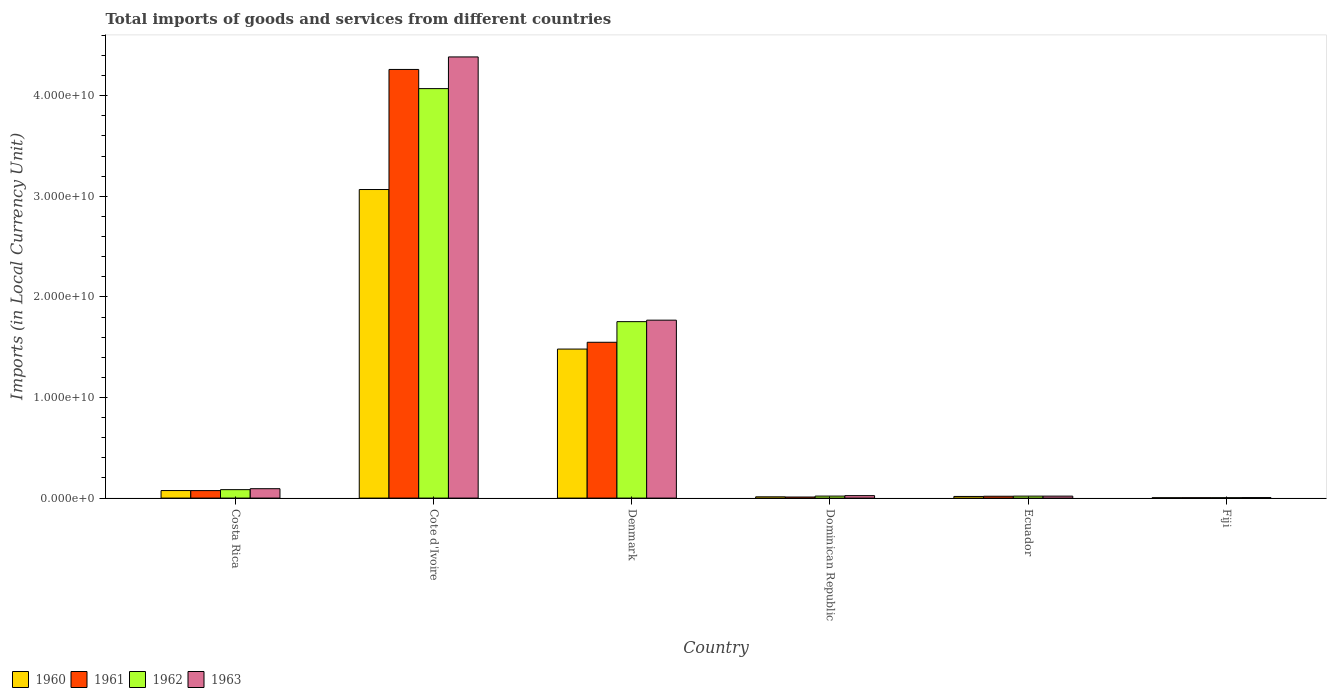How many different coloured bars are there?
Provide a short and direct response. 4. How many groups of bars are there?
Offer a very short reply. 6. Are the number of bars on each tick of the X-axis equal?
Give a very brief answer. Yes. How many bars are there on the 2nd tick from the right?
Give a very brief answer. 4. Across all countries, what is the maximum Amount of goods and services imports in 1962?
Offer a terse response. 4.07e+1. Across all countries, what is the minimum Amount of goods and services imports in 1960?
Your answer should be very brief. 3.56e+07. In which country was the Amount of goods and services imports in 1962 maximum?
Your answer should be very brief. Cote d'Ivoire. In which country was the Amount of goods and services imports in 1960 minimum?
Ensure brevity in your answer.  Fiji. What is the total Amount of goods and services imports in 1963 in the graph?
Ensure brevity in your answer.  6.30e+1. What is the difference between the Amount of goods and services imports in 1963 in Costa Rica and that in Denmark?
Provide a succinct answer. -1.68e+1. What is the difference between the Amount of goods and services imports in 1962 in Dominican Republic and the Amount of goods and services imports in 1961 in Cote d'Ivoire?
Your answer should be compact. -4.24e+1. What is the average Amount of goods and services imports in 1960 per country?
Your answer should be very brief. 7.76e+09. What is the difference between the Amount of goods and services imports of/in 1960 and Amount of goods and services imports of/in 1963 in Dominican Republic?
Give a very brief answer. -1.18e+08. In how many countries, is the Amount of goods and services imports in 1960 greater than 18000000000 LCU?
Ensure brevity in your answer.  1. What is the ratio of the Amount of goods and services imports in 1960 in Cote d'Ivoire to that in Fiji?
Make the answer very short. 861.66. Is the Amount of goods and services imports in 1960 in Dominican Republic less than that in Ecuador?
Provide a succinct answer. Yes. Is the difference between the Amount of goods and services imports in 1960 in Cote d'Ivoire and Denmark greater than the difference between the Amount of goods and services imports in 1963 in Cote d'Ivoire and Denmark?
Keep it short and to the point. No. What is the difference between the highest and the second highest Amount of goods and services imports in 1963?
Offer a terse response. 1.68e+1. What is the difference between the highest and the lowest Amount of goods and services imports in 1963?
Provide a short and direct response. 4.38e+1. In how many countries, is the Amount of goods and services imports in 1960 greater than the average Amount of goods and services imports in 1960 taken over all countries?
Your answer should be compact. 2. Is the sum of the Amount of goods and services imports in 1963 in Costa Rica and Denmark greater than the maximum Amount of goods and services imports in 1960 across all countries?
Ensure brevity in your answer.  No. What does the 3rd bar from the left in Denmark represents?
Your answer should be very brief. 1962. What does the 1st bar from the right in Cote d'Ivoire represents?
Provide a succinct answer. 1963. How many bars are there?
Give a very brief answer. 24. Does the graph contain any zero values?
Provide a succinct answer. No. Does the graph contain grids?
Your answer should be very brief. No. How many legend labels are there?
Offer a terse response. 4. What is the title of the graph?
Keep it short and to the point. Total imports of goods and services from different countries. Does "2005" appear as one of the legend labels in the graph?
Your answer should be compact. No. What is the label or title of the X-axis?
Make the answer very short. Country. What is the label or title of the Y-axis?
Offer a very short reply. Imports (in Local Currency Unit). What is the Imports (in Local Currency Unit) in 1960 in Costa Rica?
Your response must be concise. 7.49e+08. What is the Imports (in Local Currency Unit) in 1961 in Costa Rica?
Make the answer very short. 7.44e+08. What is the Imports (in Local Currency Unit) in 1962 in Costa Rica?
Keep it short and to the point. 8.40e+08. What is the Imports (in Local Currency Unit) of 1963 in Costa Rica?
Ensure brevity in your answer.  9.34e+08. What is the Imports (in Local Currency Unit) in 1960 in Cote d'Ivoire?
Your answer should be very brief. 3.07e+1. What is the Imports (in Local Currency Unit) of 1961 in Cote d'Ivoire?
Give a very brief answer. 4.26e+1. What is the Imports (in Local Currency Unit) in 1962 in Cote d'Ivoire?
Your answer should be compact. 4.07e+1. What is the Imports (in Local Currency Unit) of 1963 in Cote d'Ivoire?
Offer a very short reply. 4.39e+1. What is the Imports (in Local Currency Unit) in 1960 in Denmark?
Your answer should be very brief. 1.48e+1. What is the Imports (in Local Currency Unit) in 1961 in Denmark?
Give a very brief answer. 1.55e+1. What is the Imports (in Local Currency Unit) in 1962 in Denmark?
Give a very brief answer. 1.75e+1. What is the Imports (in Local Currency Unit) of 1963 in Denmark?
Make the answer very short. 1.77e+1. What is the Imports (in Local Currency Unit) of 1960 in Dominican Republic?
Offer a very short reply. 1.26e+08. What is the Imports (in Local Currency Unit) in 1961 in Dominican Republic?
Provide a short and direct response. 1.07e+08. What is the Imports (in Local Currency Unit) of 1962 in Dominican Republic?
Ensure brevity in your answer.  1.99e+08. What is the Imports (in Local Currency Unit) of 1963 in Dominican Republic?
Your answer should be very brief. 2.44e+08. What is the Imports (in Local Currency Unit) in 1960 in Ecuador?
Your answer should be compact. 1.64e+08. What is the Imports (in Local Currency Unit) in 1961 in Ecuador?
Offer a terse response. 1.83e+08. What is the Imports (in Local Currency Unit) of 1962 in Ecuador?
Provide a succinct answer. 1.97e+08. What is the Imports (in Local Currency Unit) of 1963 in Ecuador?
Provide a succinct answer. 1.96e+08. What is the Imports (in Local Currency Unit) in 1960 in Fiji?
Make the answer very short. 3.56e+07. What is the Imports (in Local Currency Unit) of 1961 in Fiji?
Offer a terse response. 3.79e+07. What is the Imports (in Local Currency Unit) in 1962 in Fiji?
Make the answer very short. 3.79e+07. What is the Imports (in Local Currency Unit) of 1963 in Fiji?
Offer a very short reply. 5.00e+07. Across all countries, what is the maximum Imports (in Local Currency Unit) in 1960?
Keep it short and to the point. 3.07e+1. Across all countries, what is the maximum Imports (in Local Currency Unit) of 1961?
Your response must be concise. 4.26e+1. Across all countries, what is the maximum Imports (in Local Currency Unit) of 1962?
Offer a terse response. 4.07e+1. Across all countries, what is the maximum Imports (in Local Currency Unit) of 1963?
Provide a succinct answer. 4.39e+1. Across all countries, what is the minimum Imports (in Local Currency Unit) in 1960?
Ensure brevity in your answer.  3.56e+07. Across all countries, what is the minimum Imports (in Local Currency Unit) in 1961?
Make the answer very short. 3.79e+07. Across all countries, what is the minimum Imports (in Local Currency Unit) of 1962?
Your answer should be very brief. 3.79e+07. What is the total Imports (in Local Currency Unit) in 1960 in the graph?
Offer a terse response. 4.66e+1. What is the total Imports (in Local Currency Unit) in 1961 in the graph?
Make the answer very short. 5.92e+1. What is the total Imports (in Local Currency Unit) of 1962 in the graph?
Provide a succinct answer. 5.95e+1. What is the total Imports (in Local Currency Unit) of 1963 in the graph?
Your answer should be compact. 6.30e+1. What is the difference between the Imports (in Local Currency Unit) of 1960 in Costa Rica and that in Cote d'Ivoire?
Make the answer very short. -2.99e+1. What is the difference between the Imports (in Local Currency Unit) in 1961 in Costa Rica and that in Cote d'Ivoire?
Ensure brevity in your answer.  -4.19e+1. What is the difference between the Imports (in Local Currency Unit) of 1962 in Costa Rica and that in Cote d'Ivoire?
Provide a short and direct response. -3.99e+1. What is the difference between the Imports (in Local Currency Unit) of 1963 in Costa Rica and that in Cote d'Ivoire?
Ensure brevity in your answer.  -4.29e+1. What is the difference between the Imports (in Local Currency Unit) of 1960 in Costa Rica and that in Denmark?
Provide a short and direct response. -1.41e+1. What is the difference between the Imports (in Local Currency Unit) of 1961 in Costa Rica and that in Denmark?
Your answer should be compact. -1.47e+1. What is the difference between the Imports (in Local Currency Unit) in 1962 in Costa Rica and that in Denmark?
Offer a terse response. -1.67e+1. What is the difference between the Imports (in Local Currency Unit) in 1963 in Costa Rica and that in Denmark?
Give a very brief answer. -1.68e+1. What is the difference between the Imports (in Local Currency Unit) of 1960 in Costa Rica and that in Dominican Republic?
Keep it short and to the point. 6.22e+08. What is the difference between the Imports (in Local Currency Unit) in 1961 in Costa Rica and that in Dominican Republic?
Your answer should be very brief. 6.37e+08. What is the difference between the Imports (in Local Currency Unit) of 1962 in Costa Rica and that in Dominican Republic?
Make the answer very short. 6.40e+08. What is the difference between the Imports (in Local Currency Unit) of 1963 in Costa Rica and that in Dominican Republic?
Your response must be concise. 6.90e+08. What is the difference between the Imports (in Local Currency Unit) of 1960 in Costa Rica and that in Ecuador?
Your response must be concise. 5.85e+08. What is the difference between the Imports (in Local Currency Unit) in 1961 in Costa Rica and that in Ecuador?
Offer a very short reply. 5.61e+08. What is the difference between the Imports (in Local Currency Unit) of 1962 in Costa Rica and that in Ecuador?
Provide a short and direct response. 6.43e+08. What is the difference between the Imports (in Local Currency Unit) in 1963 in Costa Rica and that in Ecuador?
Give a very brief answer. 7.38e+08. What is the difference between the Imports (in Local Currency Unit) of 1960 in Costa Rica and that in Fiji?
Your answer should be very brief. 7.13e+08. What is the difference between the Imports (in Local Currency Unit) of 1961 in Costa Rica and that in Fiji?
Your answer should be compact. 7.06e+08. What is the difference between the Imports (in Local Currency Unit) in 1962 in Costa Rica and that in Fiji?
Ensure brevity in your answer.  8.02e+08. What is the difference between the Imports (in Local Currency Unit) of 1963 in Costa Rica and that in Fiji?
Offer a very short reply. 8.84e+08. What is the difference between the Imports (in Local Currency Unit) in 1960 in Cote d'Ivoire and that in Denmark?
Keep it short and to the point. 1.59e+1. What is the difference between the Imports (in Local Currency Unit) in 1961 in Cote d'Ivoire and that in Denmark?
Provide a succinct answer. 2.71e+1. What is the difference between the Imports (in Local Currency Unit) in 1962 in Cote d'Ivoire and that in Denmark?
Provide a succinct answer. 2.32e+1. What is the difference between the Imports (in Local Currency Unit) of 1963 in Cote d'Ivoire and that in Denmark?
Your response must be concise. 2.62e+1. What is the difference between the Imports (in Local Currency Unit) of 1960 in Cote d'Ivoire and that in Dominican Republic?
Offer a terse response. 3.05e+1. What is the difference between the Imports (in Local Currency Unit) of 1961 in Cote d'Ivoire and that in Dominican Republic?
Provide a succinct answer. 4.25e+1. What is the difference between the Imports (in Local Currency Unit) of 1962 in Cote d'Ivoire and that in Dominican Republic?
Your answer should be compact. 4.05e+1. What is the difference between the Imports (in Local Currency Unit) in 1963 in Cote d'Ivoire and that in Dominican Republic?
Ensure brevity in your answer.  4.36e+1. What is the difference between the Imports (in Local Currency Unit) in 1960 in Cote d'Ivoire and that in Ecuador?
Ensure brevity in your answer.  3.05e+1. What is the difference between the Imports (in Local Currency Unit) in 1961 in Cote d'Ivoire and that in Ecuador?
Your answer should be compact. 4.24e+1. What is the difference between the Imports (in Local Currency Unit) of 1962 in Cote d'Ivoire and that in Ecuador?
Give a very brief answer. 4.05e+1. What is the difference between the Imports (in Local Currency Unit) in 1963 in Cote d'Ivoire and that in Ecuador?
Offer a terse response. 4.37e+1. What is the difference between the Imports (in Local Currency Unit) in 1960 in Cote d'Ivoire and that in Fiji?
Make the answer very short. 3.06e+1. What is the difference between the Imports (in Local Currency Unit) of 1961 in Cote d'Ivoire and that in Fiji?
Keep it short and to the point. 4.26e+1. What is the difference between the Imports (in Local Currency Unit) in 1962 in Cote d'Ivoire and that in Fiji?
Offer a very short reply. 4.07e+1. What is the difference between the Imports (in Local Currency Unit) in 1963 in Cote d'Ivoire and that in Fiji?
Your response must be concise. 4.38e+1. What is the difference between the Imports (in Local Currency Unit) in 1960 in Denmark and that in Dominican Republic?
Ensure brevity in your answer.  1.47e+1. What is the difference between the Imports (in Local Currency Unit) of 1961 in Denmark and that in Dominican Republic?
Your answer should be compact. 1.54e+1. What is the difference between the Imports (in Local Currency Unit) in 1962 in Denmark and that in Dominican Republic?
Keep it short and to the point. 1.73e+1. What is the difference between the Imports (in Local Currency Unit) of 1963 in Denmark and that in Dominican Republic?
Offer a terse response. 1.74e+1. What is the difference between the Imports (in Local Currency Unit) in 1960 in Denmark and that in Ecuador?
Offer a very short reply. 1.47e+1. What is the difference between the Imports (in Local Currency Unit) in 1961 in Denmark and that in Ecuador?
Give a very brief answer. 1.53e+1. What is the difference between the Imports (in Local Currency Unit) in 1962 in Denmark and that in Ecuador?
Ensure brevity in your answer.  1.73e+1. What is the difference between the Imports (in Local Currency Unit) of 1963 in Denmark and that in Ecuador?
Your answer should be very brief. 1.75e+1. What is the difference between the Imports (in Local Currency Unit) of 1960 in Denmark and that in Fiji?
Your answer should be compact. 1.48e+1. What is the difference between the Imports (in Local Currency Unit) of 1961 in Denmark and that in Fiji?
Ensure brevity in your answer.  1.55e+1. What is the difference between the Imports (in Local Currency Unit) of 1962 in Denmark and that in Fiji?
Your answer should be compact. 1.75e+1. What is the difference between the Imports (in Local Currency Unit) of 1963 in Denmark and that in Fiji?
Keep it short and to the point. 1.76e+1. What is the difference between the Imports (in Local Currency Unit) of 1960 in Dominican Republic and that in Ecuador?
Offer a very short reply. -3.75e+07. What is the difference between the Imports (in Local Currency Unit) in 1961 in Dominican Republic and that in Ecuador?
Offer a terse response. -7.66e+07. What is the difference between the Imports (in Local Currency Unit) of 1962 in Dominican Republic and that in Ecuador?
Give a very brief answer. 2.37e+06. What is the difference between the Imports (in Local Currency Unit) in 1963 in Dominican Republic and that in Ecuador?
Keep it short and to the point. 4.81e+07. What is the difference between the Imports (in Local Currency Unit) of 1960 in Dominican Republic and that in Fiji?
Your response must be concise. 9.09e+07. What is the difference between the Imports (in Local Currency Unit) of 1961 in Dominican Republic and that in Fiji?
Provide a succinct answer. 6.90e+07. What is the difference between the Imports (in Local Currency Unit) in 1962 in Dominican Republic and that in Fiji?
Give a very brief answer. 1.61e+08. What is the difference between the Imports (in Local Currency Unit) in 1963 in Dominican Republic and that in Fiji?
Ensure brevity in your answer.  1.94e+08. What is the difference between the Imports (in Local Currency Unit) in 1960 in Ecuador and that in Fiji?
Offer a terse response. 1.28e+08. What is the difference between the Imports (in Local Currency Unit) of 1961 in Ecuador and that in Fiji?
Keep it short and to the point. 1.46e+08. What is the difference between the Imports (in Local Currency Unit) of 1962 in Ecuador and that in Fiji?
Make the answer very short. 1.59e+08. What is the difference between the Imports (in Local Currency Unit) in 1963 in Ecuador and that in Fiji?
Provide a short and direct response. 1.46e+08. What is the difference between the Imports (in Local Currency Unit) of 1960 in Costa Rica and the Imports (in Local Currency Unit) of 1961 in Cote d'Ivoire?
Make the answer very short. -4.19e+1. What is the difference between the Imports (in Local Currency Unit) in 1960 in Costa Rica and the Imports (in Local Currency Unit) in 1962 in Cote d'Ivoire?
Your response must be concise. -4.00e+1. What is the difference between the Imports (in Local Currency Unit) of 1960 in Costa Rica and the Imports (in Local Currency Unit) of 1963 in Cote d'Ivoire?
Give a very brief answer. -4.31e+1. What is the difference between the Imports (in Local Currency Unit) of 1961 in Costa Rica and the Imports (in Local Currency Unit) of 1962 in Cote d'Ivoire?
Your answer should be very brief. -4.00e+1. What is the difference between the Imports (in Local Currency Unit) of 1961 in Costa Rica and the Imports (in Local Currency Unit) of 1963 in Cote d'Ivoire?
Keep it short and to the point. -4.31e+1. What is the difference between the Imports (in Local Currency Unit) in 1962 in Costa Rica and the Imports (in Local Currency Unit) in 1963 in Cote d'Ivoire?
Your answer should be compact. -4.30e+1. What is the difference between the Imports (in Local Currency Unit) in 1960 in Costa Rica and the Imports (in Local Currency Unit) in 1961 in Denmark?
Give a very brief answer. -1.47e+1. What is the difference between the Imports (in Local Currency Unit) of 1960 in Costa Rica and the Imports (in Local Currency Unit) of 1962 in Denmark?
Give a very brief answer. -1.68e+1. What is the difference between the Imports (in Local Currency Unit) in 1960 in Costa Rica and the Imports (in Local Currency Unit) in 1963 in Denmark?
Offer a very short reply. -1.69e+1. What is the difference between the Imports (in Local Currency Unit) of 1961 in Costa Rica and the Imports (in Local Currency Unit) of 1962 in Denmark?
Your answer should be very brief. -1.68e+1. What is the difference between the Imports (in Local Currency Unit) of 1961 in Costa Rica and the Imports (in Local Currency Unit) of 1963 in Denmark?
Your answer should be compact. -1.69e+1. What is the difference between the Imports (in Local Currency Unit) of 1962 in Costa Rica and the Imports (in Local Currency Unit) of 1963 in Denmark?
Make the answer very short. -1.68e+1. What is the difference between the Imports (in Local Currency Unit) in 1960 in Costa Rica and the Imports (in Local Currency Unit) in 1961 in Dominican Republic?
Provide a succinct answer. 6.42e+08. What is the difference between the Imports (in Local Currency Unit) of 1960 in Costa Rica and the Imports (in Local Currency Unit) of 1962 in Dominican Republic?
Ensure brevity in your answer.  5.50e+08. What is the difference between the Imports (in Local Currency Unit) of 1960 in Costa Rica and the Imports (in Local Currency Unit) of 1963 in Dominican Republic?
Your answer should be compact. 5.04e+08. What is the difference between the Imports (in Local Currency Unit) in 1961 in Costa Rica and the Imports (in Local Currency Unit) in 1962 in Dominican Republic?
Your answer should be very brief. 5.45e+08. What is the difference between the Imports (in Local Currency Unit) of 1961 in Costa Rica and the Imports (in Local Currency Unit) of 1963 in Dominican Republic?
Your answer should be very brief. 5.00e+08. What is the difference between the Imports (in Local Currency Unit) of 1962 in Costa Rica and the Imports (in Local Currency Unit) of 1963 in Dominican Republic?
Keep it short and to the point. 5.95e+08. What is the difference between the Imports (in Local Currency Unit) of 1960 in Costa Rica and the Imports (in Local Currency Unit) of 1961 in Ecuador?
Offer a terse response. 5.65e+08. What is the difference between the Imports (in Local Currency Unit) in 1960 in Costa Rica and the Imports (in Local Currency Unit) in 1962 in Ecuador?
Ensure brevity in your answer.  5.52e+08. What is the difference between the Imports (in Local Currency Unit) of 1960 in Costa Rica and the Imports (in Local Currency Unit) of 1963 in Ecuador?
Give a very brief answer. 5.53e+08. What is the difference between the Imports (in Local Currency Unit) of 1961 in Costa Rica and the Imports (in Local Currency Unit) of 1962 in Ecuador?
Provide a short and direct response. 5.47e+08. What is the difference between the Imports (in Local Currency Unit) of 1961 in Costa Rica and the Imports (in Local Currency Unit) of 1963 in Ecuador?
Give a very brief answer. 5.48e+08. What is the difference between the Imports (in Local Currency Unit) of 1962 in Costa Rica and the Imports (in Local Currency Unit) of 1963 in Ecuador?
Make the answer very short. 6.43e+08. What is the difference between the Imports (in Local Currency Unit) of 1960 in Costa Rica and the Imports (in Local Currency Unit) of 1961 in Fiji?
Provide a succinct answer. 7.11e+08. What is the difference between the Imports (in Local Currency Unit) in 1960 in Costa Rica and the Imports (in Local Currency Unit) in 1962 in Fiji?
Offer a very short reply. 7.11e+08. What is the difference between the Imports (in Local Currency Unit) in 1960 in Costa Rica and the Imports (in Local Currency Unit) in 1963 in Fiji?
Offer a terse response. 6.99e+08. What is the difference between the Imports (in Local Currency Unit) in 1961 in Costa Rica and the Imports (in Local Currency Unit) in 1962 in Fiji?
Provide a short and direct response. 7.06e+08. What is the difference between the Imports (in Local Currency Unit) in 1961 in Costa Rica and the Imports (in Local Currency Unit) in 1963 in Fiji?
Give a very brief answer. 6.94e+08. What is the difference between the Imports (in Local Currency Unit) in 1962 in Costa Rica and the Imports (in Local Currency Unit) in 1963 in Fiji?
Your answer should be very brief. 7.90e+08. What is the difference between the Imports (in Local Currency Unit) of 1960 in Cote d'Ivoire and the Imports (in Local Currency Unit) of 1961 in Denmark?
Offer a very short reply. 1.52e+1. What is the difference between the Imports (in Local Currency Unit) of 1960 in Cote d'Ivoire and the Imports (in Local Currency Unit) of 1962 in Denmark?
Offer a very short reply. 1.31e+1. What is the difference between the Imports (in Local Currency Unit) of 1960 in Cote d'Ivoire and the Imports (in Local Currency Unit) of 1963 in Denmark?
Your answer should be very brief. 1.30e+1. What is the difference between the Imports (in Local Currency Unit) in 1961 in Cote d'Ivoire and the Imports (in Local Currency Unit) in 1962 in Denmark?
Offer a very short reply. 2.51e+1. What is the difference between the Imports (in Local Currency Unit) in 1961 in Cote d'Ivoire and the Imports (in Local Currency Unit) in 1963 in Denmark?
Make the answer very short. 2.49e+1. What is the difference between the Imports (in Local Currency Unit) in 1962 in Cote d'Ivoire and the Imports (in Local Currency Unit) in 1963 in Denmark?
Make the answer very short. 2.30e+1. What is the difference between the Imports (in Local Currency Unit) of 1960 in Cote d'Ivoire and the Imports (in Local Currency Unit) of 1961 in Dominican Republic?
Offer a terse response. 3.06e+1. What is the difference between the Imports (in Local Currency Unit) of 1960 in Cote d'Ivoire and the Imports (in Local Currency Unit) of 1962 in Dominican Republic?
Give a very brief answer. 3.05e+1. What is the difference between the Imports (in Local Currency Unit) of 1960 in Cote d'Ivoire and the Imports (in Local Currency Unit) of 1963 in Dominican Republic?
Give a very brief answer. 3.04e+1. What is the difference between the Imports (in Local Currency Unit) of 1961 in Cote d'Ivoire and the Imports (in Local Currency Unit) of 1962 in Dominican Republic?
Offer a very short reply. 4.24e+1. What is the difference between the Imports (in Local Currency Unit) of 1961 in Cote d'Ivoire and the Imports (in Local Currency Unit) of 1963 in Dominican Republic?
Offer a very short reply. 4.24e+1. What is the difference between the Imports (in Local Currency Unit) in 1962 in Cote d'Ivoire and the Imports (in Local Currency Unit) in 1963 in Dominican Republic?
Provide a succinct answer. 4.05e+1. What is the difference between the Imports (in Local Currency Unit) of 1960 in Cote d'Ivoire and the Imports (in Local Currency Unit) of 1961 in Ecuador?
Keep it short and to the point. 3.05e+1. What is the difference between the Imports (in Local Currency Unit) of 1960 in Cote d'Ivoire and the Imports (in Local Currency Unit) of 1962 in Ecuador?
Provide a succinct answer. 3.05e+1. What is the difference between the Imports (in Local Currency Unit) in 1960 in Cote d'Ivoire and the Imports (in Local Currency Unit) in 1963 in Ecuador?
Ensure brevity in your answer.  3.05e+1. What is the difference between the Imports (in Local Currency Unit) of 1961 in Cote d'Ivoire and the Imports (in Local Currency Unit) of 1962 in Ecuador?
Provide a short and direct response. 4.24e+1. What is the difference between the Imports (in Local Currency Unit) in 1961 in Cote d'Ivoire and the Imports (in Local Currency Unit) in 1963 in Ecuador?
Keep it short and to the point. 4.24e+1. What is the difference between the Imports (in Local Currency Unit) of 1962 in Cote d'Ivoire and the Imports (in Local Currency Unit) of 1963 in Ecuador?
Make the answer very short. 4.05e+1. What is the difference between the Imports (in Local Currency Unit) of 1960 in Cote d'Ivoire and the Imports (in Local Currency Unit) of 1961 in Fiji?
Provide a short and direct response. 3.06e+1. What is the difference between the Imports (in Local Currency Unit) in 1960 in Cote d'Ivoire and the Imports (in Local Currency Unit) in 1962 in Fiji?
Your response must be concise. 3.06e+1. What is the difference between the Imports (in Local Currency Unit) in 1960 in Cote d'Ivoire and the Imports (in Local Currency Unit) in 1963 in Fiji?
Keep it short and to the point. 3.06e+1. What is the difference between the Imports (in Local Currency Unit) in 1961 in Cote d'Ivoire and the Imports (in Local Currency Unit) in 1962 in Fiji?
Offer a terse response. 4.26e+1. What is the difference between the Imports (in Local Currency Unit) in 1961 in Cote d'Ivoire and the Imports (in Local Currency Unit) in 1963 in Fiji?
Make the answer very short. 4.26e+1. What is the difference between the Imports (in Local Currency Unit) in 1962 in Cote d'Ivoire and the Imports (in Local Currency Unit) in 1963 in Fiji?
Give a very brief answer. 4.07e+1. What is the difference between the Imports (in Local Currency Unit) in 1960 in Denmark and the Imports (in Local Currency Unit) in 1961 in Dominican Republic?
Your answer should be compact. 1.47e+1. What is the difference between the Imports (in Local Currency Unit) of 1960 in Denmark and the Imports (in Local Currency Unit) of 1962 in Dominican Republic?
Ensure brevity in your answer.  1.46e+1. What is the difference between the Imports (in Local Currency Unit) in 1960 in Denmark and the Imports (in Local Currency Unit) in 1963 in Dominican Republic?
Offer a very short reply. 1.46e+1. What is the difference between the Imports (in Local Currency Unit) of 1961 in Denmark and the Imports (in Local Currency Unit) of 1962 in Dominican Republic?
Your answer should be very brief. 1.53e+1. What is the difference between the Imports (in Local Currency Unit) in 1961 in Denmark and the Imports (in Local Currency Unit) in 1963 in Dominican Republic?
Ensure brevity in your answer.  1.52e+1. What is the difference between the Imports (in Local Currency Unit) of 1962 in Denmark and the Imports (in Local Currency Unit) of 1963 in Dominican Republic?
Your response must be concise. 1.73e+1. What is the difference between the Imports (in Local Currency Unit) in 1960 in Denmark and the Imports (in Local Currency Unit) in 1961 in Ecuador?
Offer a very short reply. 1.46e+1. What is the difference between the Imports (in Local Currency Unit) in 1960 in Denmark and the Imports (in Local Currency Unit) in 1962 in Ecuador?
Make the answer very short. 1.46e+1. What is the difference between the Imports (in Local Currency Unit) of 1960 in Denmark and the Imports (in Local Currency Unit) of 1963 in Ecuador?
Your answer should be very brief. 1.46e+1. What is the difference between the Imports (in Local Currency Unit) of 1961 in Denmark and the Imports (in Local Currency Unit) of 1962 in Ecuador?
Your answer should be compact. 1.53e+1. What is the difference between the Imports (in Local Currency Unit) of 1961 in Denmark and the Imports (in Local Currency Unit) of 1963 in Ecuador?
Ensure brevity in your answer.  1.53e+1. What is the difference between the Imports (in Local Currency Unit) in 1962 in Denmark and the Imports (in Local Currency Unit) in 1963 in Ecuador?
Keep it short and to the point. 1.73e+1. What is the difference between the Imports (in Local Currency Unit) in 1960 in Denmark and the Imports (in Local Currency Unit) in 1961 in Fiji?
Make the answer very short. 1.48e+1. What is the difference between the Imports (in Local Currency Unit) in 1960 in Denmark and the Imports (in Local Currency Unit) in 1962 in Fiji?
Make the answer very short. 1.48e+1. What is the difference between the Imports (in Local Currency Unit) in 1960 in Denmark and the Imports (in Local Currency Unit) in 1963 in Fiji?
Keep it short and to the point. 1.48e+1. What is the difference between the Imports (in Local Currency Unit) in 1961 in Denmark and the Imports (in Local Currency Unit) in 1962 in Fiji?
Your answer should be compact. 1.55e+1. What is the difference between the Imports (in Local Currency Unit) of 1961 in Denmark and the Imports (in Local Currency Unit) of 1963 in Fiji?
Keep it short and to the point. 1.54e+1. What is the difference between the Imports (in Local Currency Unit) in 1962 in Denmark and the Imports (in Local Currency Unit) in 1963 in Fiji?
Offer a very short reply. 1.75e+1. What is the difference between the Imports (in Local Currency Unit) of 1960 in Dominican Republic and the Imports (in Local Currency Unit) of 1961 in Ecuador?
Ensure brevity in your answer.  -5.70e+07. What is the difference between the Imports (in Local Currency Unit) of 1960 in Dominican Republic and the Imports (in Local Currency Unit) of 1962 in Ecuador?
Provide a short and direct response. -7.04e+07. What is the difference between the Imports (in Local Currency Unit) in 1960 in Dominican Republic and the Imports (in Local Currency Unit) in 1963 in Ecuador?
Provide a short and direct response. -6.98e+07. What is the difference between the Imports (in Local Currency Unit) of 1961 in Dominican Republic and the Imports (in Local Currency Unit) of 1962 in Ecuador?
Offer a terse response. -9.00e+07. What is the difference between the Imports (in Local Currency Unit) in 1961 in Dominican Republic and the Imports (in Local Currency Unit) in 1963 in Ecuador?
Give a very brief answer. -8.94e+07. What is the difference between the Imports (in Local Currency Unit) in 1962 in Dominican Republic and the Imports (in Local Currency Unit) in 1963 in Ecuador?
Give a very brief answer. 3.04e+06. What is the difference between the Imports (in Local Currency Unit) of 1960 in Dominican Republic and the Imports (in Local Currency Unit) of 1961 in Fiji?
Give a very brief answer. 8.86e+07. What is the difference between the Imports (in Local Currency Unit) in 1960 in Dominican Republic and the Imports (in Local Currency Unit) in 1962 in Fiji?
Provide a short and direct response. 8.86e+07. What is the difference between the Imports (in Local Currency Unit) in 1960 in Dominican Republic and the Imports (in Local Currency Unit) in 1963 in Fiji?
Your answer should be compact. 7.65e+07. What is the difference between the Imports (in Local Currency Unit) in 1961 in Dominican Republic and the Imports (in Local Currency Unit) in 1962 in Fiji?
Provide a succinct answer. 6.90e+07. What is the difference between the Imports (in Local Currency Unit) of 1961 in Dominican Republic and the Imports (in Local Currency Unit) of 1963 in Fiji?
Give a very brief answer. 5.69e+07. What is the difference between the Imports (in Local Currency Unit) of 1962 in Dominican Republic and the Imports (in Local Currency Unit) of 1963 in Fiji?
Offer a terse response. 1.49e+08. What is the difference between the Imports (in Local Currency Unit) in 1960 in Ecuador and the Imports (in Local Currency Unit) in 1961 in Fiji?
Provide a short and direct response. 1.26e+08. What is the difference between the Imports (in Local Currency Unit) of 1960 in Ecuador and the Imports (in Local Currency Unit) of 1962 in Fiji?
Give a very brief answer. 1.26e+08. What is the difference between the Imports (in Local Currency Unit) in 1960 in Ecuador and the Imports (in Local Currency Unit) in 1963 in Fiji?
Ensure brevity in your answer.  1.14e+08. What is the difference between the Imports (in Local Currency Unit) in 1961 in Ecuador and the Imports (in Local Currency Unit) in 1962 in Fiji?
Provide a short and direct response. 1.46e+08. What is the difference between the Imports (in Local Currency Unit) in 1961 in Ecuador and the Imports (in Local Currency Unit) in 1963 in Fiji?
Make the answer very short. 1.33e+08. What is the difference between the Imports (in Local Currency Unit) of 1962 in Ecuador and the Imports (in Local Currency Unit) of 1963 in Fiji?
Provide a succinct answer. 1.47e+08. What is the average Imports (in Local Currency Unit) of 1960 per country?
Make the answer very short. 7.76e+09. What is the average Imports (in Local Currency Unit) of 1961 per country?
Provide a succinct answer. 9.86e+09. What is the average Imports (in Local Currency Unit) of 1962 per country?
Offer a terse response. 9.92e+09. What is the average Imports (in Local Currency Unit) of 1963 per country?
Provide a succinct answer. 1.05e+1. What is the difference between the Imports (in Local Currency Unit) of 1960 and Imports (in Local Currency Unit) of 1961 in Costa Rica?
Provide a succinct answer. 4.80e+06. What is the difference between the Imports (in Local Currency Unit) of 1960 and Imports (in Local Currency Unit) of 1962 in Costa Rica?
Keep it short and to the point. -9.07e+07. What is the difference between the Imports (in Local Currency Unit) of 1960 and Imports (in Local Currency Unit) of 1963 in Costa Rica?
Offer a terse response. -1.85e+08. What is the difference between the Imports (in Local Currency Unit) in 1961 and Imports (in Local Currency Unit) in 1962 in Costa Rica?
Your response must be concise. -9.55e+07. What is the difference between the Imports (in Local Currency Unit) of 1961 and Imports (in Local Currency Unit) of 1963 in Costa Rica?
Offer a very short reply. -1.90e+08. What is the difference between the Imports (in Local Currency Unit) in 1962 and Imports (in Local Currency Unit) in 1963 in Costa Rica?
Your answer should be compact. -9.44e+07. What is the difference between the Imports (in Local Currency Unit) in 1960 and Imports (in Local Currency Unit) in 1961 in Cote d'Ivoire?
Offer a terse response. -1.19e+1. What is the difference between the Imports (in Local Currency Unit) of 1960 and Imports (in Local Currency Unit) of 1962 in Cote d'Ivoire?
Your answer should be very brief. -1.00e+1. What is the difference between the Imports (in Local Currency Unit) of 1960 and Imports (in Local Currency Unit) of 1963 in Cote d'Ivoire?
Your response must be concise. -1.32e+1. What is the difference between the Imports (in Local Currency Unit) in 1961 and Imports (in Local Currency Unit) in 1962 in Cote d'Ivoire?
Your answer should be very brief. 1.91e+09. What is the difference between the Imports (in Local Currency Unit) of 1961 and Imports (in Local Currency Unit) of 1963 in Cote d'Ivoire?
Offer a very short reply. -1.24e+09. What is the difference between the Imports (in Local Currency Unit) of 1962 and Imports (in Local Currency Unit) of 1963 in Cote d'Ivoire?
Provide a succinct answer. -3.15e+09. What is the difference between the Imports (in Local Currency Unit) of 1960 and Imports (in Local Currency Unit) of 1961 in Denmark?
Make the answer very short. -6.76e+08. What is the difference between the Imports (in Local Currency Unit) in 1960 and Imports (in Local Currency Unit) in 1962 in Denmark?
Provide a succinct answer. -2.73e+09. What is the difference between the Imports (in Local Currency Unit) in 1960 and Imports (in Local Currency Unit) in 1963 in Denmark?
Provide a short and direct response. -2.87e+09. What is the difference between the Imports (in Local Currency Unit) of 1961 and Imports (in Local Currency Unit) of 1962 in Denmark?
Provide a succinct answer. -2.05e+09. What is the difference between the Imports (in Local Currency Unit) of 1961 and Imports (in Local Currency Unit) of 1963 in Denmark?
Give a very brief answer. -2.20e+09. What is the difference between the Imports (in Local Currency Unit) in 1962 and Imports (in Local Currency Unit) in 1963 in Denmark?
Offer a terse response. -1.47e+08. What is the difference between the Imports (in Local Currency Unit) of 1960 and Imports (in Local Currency Unit) of 1961 in Dominican Republic?
Keep it short and to the point. 1.96e+07. What is the difference between the Imports (in Local Currency Unit) in 1960 and Imports (in Local Currency Unit) in 1962 in Dominican Republic?
Your response must be concise. -7.28e+07. What is the difference between the Imports (in Local Currency Unit) in 1960 and Imports (in Local Currency Unit) in 1963 in Dominican Republic?
Your response must be concise. -1.18e+08. What is the difference between the Imports (in Local Currency Unit) of 1961 and Imports (in Local Currency Unit) of 1962 in Dominican Republic?
Keep it short and to the point. -9.24e+07. What is the difference between the Imports (in Local Currency Unit) of 1961 and Imports (in Local Currency Unit) of 1963 in Dominican Republic?
Provide a short and direct response. -1.38e+08. What is the difference between the Imports (in Local Currency Unit) in 1962 and Imports (in Local Currency Unit) in 1963 in Dominican Republic?
Make the answer very short. -4.51e+07. What is the difference between the Imports (in Local Currency Unit) in 1960 and Imports (in Local Currency Unit) in 1961 in Ecuador?
Make the answer very short. -1.95e+07. What is the difference between the Imports (in Local Currency Unit) of 1960 and Imports (in Local Currency Unit) of 1962 in Ecuador?
Offer a very short reply. -3.29e+07. What is the difference between the Imports (in Local Currency Unit) of 1960 and Imports (in Local Currency Unit) of 1963 in Ecuador?
Give a very brief answer. -3.23e+07. What is the difference between the Imports (in Local Currency Unit) in 1961 and Imports (in Local Currency Unit) in 1962 in Ecuador?
Your answer should be very brief. -1.34e+07. What is the difference between the Imports (in Local Currency Unit) in 1961 and Imports (in Local Currency Unit) in 1963 in Ecuador?
Offer a very short reply. -1.28e+07. What is the difference between the Imports (in Local Currency Unit) of 1962 and Imports (in Local Currency Unit) of 1963 in Ecuador?
Provide a short and direct response. 6.72e+05. What is the difference between the Imports (in Local Currency Unit) of 1960 and Imports (in Local Currency Unit) of 1961 in Fiji?
Provide a short and direct response. -2.30e+06. What is the difference between the Imports (in Local Currency Unit) of 1960 and Imports (in Local Currency Unit) of 1962 in Fiji?
Offer a very short reply. -2.30e+06. What is the difference between the Imports (in Local Currency Unit) in 1960 and Imports (in Local Currency Unit) in 1963 in Fiji?
Your response must be concise. -1.44e+07. What is the difference between the Imports (in Local Currency Unit) of 1961 and Imports (in Local Currency Unit) of 1963 in Fiji?
Offer a very short reply. -1.21e+07. What is the difference between the Imports (in Local Currency Unit) in 1962 and Imports (in Local Currency Unit) in 1963 in Fiji?
Provide a short and direct response. -1.21e+07. What is the ratio of the Imports (in Local Currency Unit) of 1960 in Costa Rica to that in Cote d'Ivoire?
Give a very brief answer. 0.02. What is the ratio of the Imports (in Local Currency Unit) in 1961 in Costa Rica to that in Cote d'Ivoire?
Offer a terse response. 0.02. What is the ratio of the Imports (in Local Currency Unit) of 1962 in Costa Rica to that in Cote d'Ivoire?
Offer a terse response. 0.02. What is the ratio of the Imports (in Local Currency Unit) in 1963 in Costa Rica to that in Cote d'Ivoire?
Your response must be concise. 0.02. What is the ratio of the Imports (in Local Currency Unit) of 1960 in Costa Rica to that in Denmark?
Provide a short and direct response. 0.05. What is the ratio of the Imports (in Local Currency Unit) in 1961 in Costa Rica to that in Denmark?
Offer a very short reply. 0.05. What is the ratio of the Imports (in Local Currency Unit) in 1962 in Costa Rica to that in Denmark?
Provide a succinct answer. 0.05. What is the ratio of the Imports (in Local Currency Unit) of 1963 in Costa Rica to that in Denmark?
Provide a short and direct response. 0.05. What is the ratio of the Imports (in Local Currency Unit) in 1960 in Costa Rica to that in Dominican Republic?
Offer a terse response. 5.92. What is the ratio of the Imports (in Local Currency Unit) of 1961 in Costa Rica to that in Dominican Republic?
Offer a terse response. 6.96. What is the ratio of the Imports (in Local Currency Unit) in 1962 in Costa Rica to that in Dominican Republic?
Offer a terse response. 4.21. What is the ratio of the Imports (in Local Currency Unit) of 1963 in Costa Rica to that in Dominican Republic?
Provide a succinct answer. 3.82. What is the ratio of the Imports (in Local Currency Unit) in 1960 in Costa Rica to that in Ecuador?
Provide a succinct answer. 4.57. What is the ratio of the Imports (in Local Currency Unit) of 1961 in Costa Rica to that in Ecuador?
Offer a terse response. 4.05. What is the ratio of the Imports (in Local Currency Unit) in 1962 in Costa Rica to that in Ecuador?
Ensure brevity in your answer.  4.26. What is the ratio of the Imports (in Local Currency Unit) of 1963 in Costa Rica to that in Ecuador?
Ensure brevity in your answer.  4.76. What is the ratio of the Imports (in Local Currency Unit) of 1960 in Costa Rica to that in Fiji?
Your answer should be compact. 21.03. What is the ratio of the Imports (in Local Currency Unit) of 1961 in Costa Rica to that in Fiji?
Your answer should be compact. 19.63. What is the ratio of the Imports (in Local Currency Unit) of 1962 in Costa Rica to that in Fiji?
Offer a terse response. 22.15. What is the ratio of the Imports (in Local Currency Unit) in 1963 in Costa Rica to that in Fiji?
Provide a short and direct response. 18.68. What is the ratio of the Imports (in Local Currency Unit) in 1960 in Cote d'Ivoire to that in Denmark?
Offer a terse response. 2.07. What is the ratio of the Imports (in Local Currency Unit) in 1961 in Cote d'Ivoire to that in Denmark?
Your response must be concise. 2.75. What is the ratio of the Imports (in Local Currency Unit) in 1962 in Cote d'Ivoire to that in Denmark?
Give a very brief answer. 2.32. What is the ratio of the Imports (in Local Currency Unit) of 1963 in Cote d'Ivoire to that in Denmark?
Offer a very short reply. 2.48. What is the ratio of the Imports (in Local Currency Unit) in 1960 in Cote d'Ivoire to that in Dominican Republic?
Your answer should be very brief. 242.49. What is the ratio of the Imports (in Local Currency Unit) of 1961 in Cote d'Ivoire to that in Dominican Republic?
Keep it short and to the point. 398.63. What is the ratio of the Imports (in Local Currency Unit) in 1962 in Cote d'Ivoire to that in Dominican Republic?
Provide a short and direct response. 204.25. What is the ratio of the Imports (in Local Currency Unit) of 1963 in Cote d'Ivoire to that in Dominican Republic?
Your answer should be compact. 179.45. What is the ratio of the Imports (in Local Currency Unit) in 1960 in Cote d'Ivoire to that in Ecuador?
Offer a terse response. 187.04. What is the ratio of the Imports (in Local Currency Unit) in 1961 in Cote d'Ivoire to that in Ecuador?
Make the answer very short. 232.24. What is the ratio of the Imports (in Local Currency Unit) in 1962 in Cote d'Ivoire to that in Ecuador?
Your response must be concise. 206.7. What is the ratio of the Imports (in Local Currency Unit) of 1963 in Cote d'Ivoire to that in Ecuador?
Offer a terse response. 223.46. What is the ratio of the Imports (in Local Currency Unit) of 1960 in Cote d'Ivoire to that in Fiji?
Your answer should be very brief. 861.66. What is the ratio of the Imports (in Local Currency Unit) in 1961 in Cote d'Ivoire to that in Fiji?
Provide a succinct answer. 1124.37. What is the ratio of the Imports (in Local Currency Unit) in 1962 in Cote d'Ivoire to that in Fiji?
Offer a very short reply. 1074.06. What is the ratio of the Imports (in Local Currency Unit) in 1963 in Cote d'Ivoire to that in Fiji?
Keep it short and to the point. 877.15. What is the ratio of the Imports (in Local Currency Unit) of 1960 in Denmark to that in Dominican Republic?
Ensure brevity in your answer.  117.11. What is the ratio of the Imports (in Local Currency Unit) in 1961 in Denmark to that in Dominican Republic?
Give a very brief answer. 144.9. What is the ratio of the Imports (in Local Currency Unit) of 1962 in Denmark to that in Dominican Republic?
Your answer should be very brief. 88.01. What is the ratio of the Imports (in Local Currency Unit) in 1963 in Denmark to that in Dominican Republic?
Provide a short and direct response. 72.37. What is the ratio of the Imports (in Local Currency Unit) in 1960 in Denmark to that in Ecuador?
Ensure brevity in your answer.  90.33. What is the ratio of the Imports (in Local Currency Unit) in 1961 in Denmark to that in Ecuador?
Ensure brevity in your answer.  84.42. What is the ratio of the Imports (in Local Currency Unit) in 1962 in Denmark to that in Ecuador?
Offer a terse response. 89.07. What is the ratio of the Imports (in Local Currency Unit) in 1963 in Denmark to that in Ecuador?
Your response must be concise. 90.12. What is the ratio of the Imports (in Local Currency Unit) in 1960 in Denmark to that in Fiji?
Ensure brevity in your answer.  416.13. What is the ratio of the Imports (in Local Currency Unit) of 1961 in Denmark to that in Fiji?
Provide a short and direct response. 408.7. What is the ratio of the Imports (in Local Currency Unit) of 1962 in Denmark to that in Fiji?
Give a very brief answer. 462.83. What is the ratio of the Imports (in Local Currency Unit) in 1963 in Denmark to that in Fiji?
Your answer should be compact. 353.76. What is the ratio of the Imports (in Local Currency Unit) in 1960 in Dominican Republic to that in Ecuador?
Ensure brevity in your answer.  0.77. What is the ratio of the Imports (in Local Currency Unit) in 1961 in Dominican Republic to that in Ecuador?
Offer a very short reply. 0.58. What is the ratio of the Imports (in Local Currency Unit) of 1963 in Dominican Republic to that in Ecuador?
Keep it short and to the point. 1.25. What is the ratio of the Imports (in Local Currency Unit) in 1960 in Dominican Republic to that in Fiji?
Make the answer very short. 3.55. What is the ratio of the Imports (in Local Currency Unit) in 1961 in Dominican Republic to that in Fiji?
Your answer should be compact. 2.82. What is the ratio of the Imports (in Local Currency Unit) of 1962 in Dominican Republic to that in Fiji?
Make the answer very short. 5.26. What is the ratio of the Imports (in Local Currency Unit) in 1963 in Dominican Republic to that in Fiji?
Give a very brief answer. 4.89. What is the ratio of the Imports (in Local Currency Unit) of 1960 in Ecuador to that in Fiji?
Offer a very short reply. 4.61. What is the ratio of the Imports (in Local Currency Unit) of 1961 in Ecuador to that in Fiji?
Your response must be concise. 4.84. What is the ratio of the Imports (in Local Currency Unit) in 1962 in Ecuador to that in Fiji?
Ensure brevity in your answer.  5.2. What is the ratio of the Imports (in Local Currency Unit) of 1963 in Ecuador to that in Fiji?
Your answer should be compact. 3.93. What is the difference between the highest and the second highest Imports (in Local Currency Unit) of 1960?
Offer a terse response. 1.59e+1. What is the difference between the highest and the second highest Imports (in Local Currency Unit) of 1961?
Give a very brief answer. 2.71e+1. What is the difference between the highest and the second highest Imports (in Local Currency Unit) in 1962?
Ensure brevity in your answer.  2.32e+1. What is the difference between the highest and the second highest Imports (in Local Currency Unit) of 1963?
Your answer should be compact. 2.62e+1. What is the difference between the highest and the lowest Imports (in Local Currency Unit) in 1960?
Give a very brief answer. 3.06e+1. What is the difference between the highest and the lowest Imports (in Local Currency Unit) of 1961?
Keep it short and to the point. 4.26e+1. What is the difference between the highest and the lowest Imports (in Local Currency Unit) of 1962?
Your response must be concise. 4.07e+1. What is the difference between the highest and the lowest Imports (in Local Currency Unit) in 1963?
Ensure brevity in your answer.  4.38e+1. 